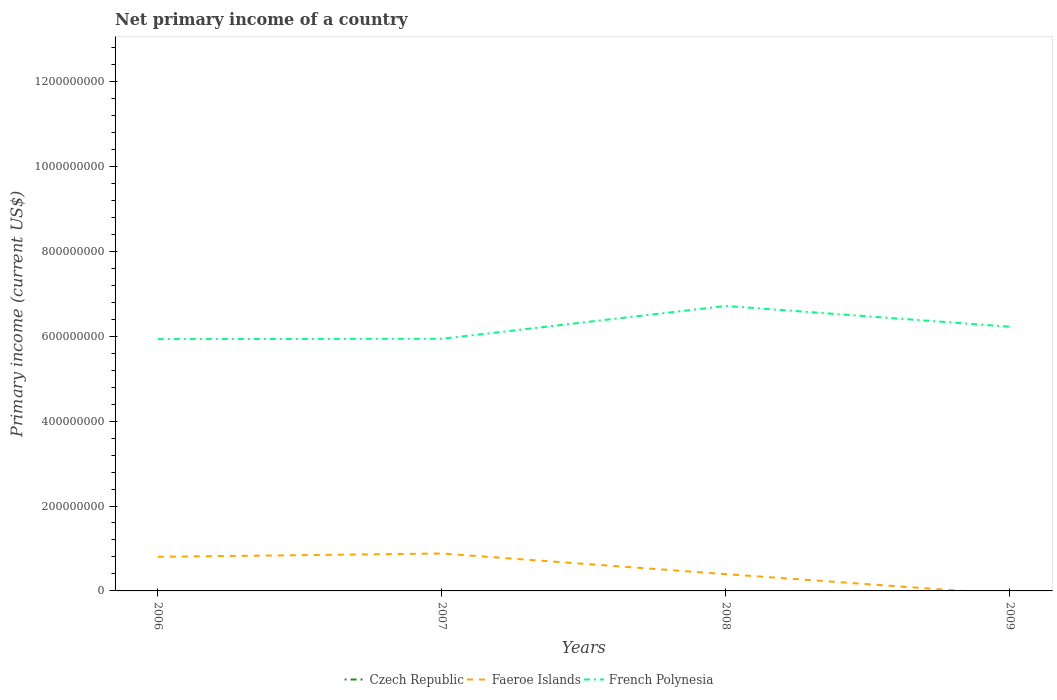Does the line corresponding to French Polynesia intersect with the line corresponding to Czech Republic?
Your response must be concise. No. Is the number of lines equal to the number of legend labels?
Give a very brief answer. No. Across all years, what is the maximum primary income in Faeroe Islands?
Provide a succinct answer. 0. What is the total primary income in Faeroe Islands in the graph?
Offer a terse response. 4.08e+07. What is the difference between the highest and the second highest primary income in Faeroe Islands?
Offer a terse response. 8.82e+07. What is the difference between the highest and the lowest primary income in Faeroe Islands?
Provide a succinct answer. 2. Is the primary income in French Polynesia strictly greater than the primary income in Czech Republic over the years?
Provide a short and direct response. No. How many lines are there?
Your answer should be compact. 2. Does the graph contain any zero values?
Provide a short and direct response. Yes. Does the graph contain grids?
Give a very brief answer. No. What is the title of the graph?
Your response must be concise. Net primary income of a country. Does "Liechtenstein" appear as one of the legend labels in the graph?
Offer a terse response. No. What is the label or title of the Y-axis?
Keep it short and to the point. Primary income (current US$). What is the Primary income (current US$) in Faeroe Islands in 2006?
Make the answer very short. 8.03e+07. What is the Primary income (current US$) of French Polynesia in 2006?
Your response must be concise. 5.93e+08. What is the Primary income (current US$) in Czech Republic in 2007?
Offer a terse response. 0. What is the Primary income (current US$) in Faeroe Islands in 2007?
Your answer should be very brief. 8.82e+07. What is the Primary income (current US$) in French Polynesia in 2007?
Ensure brevity in your answer.  5.94e+08. What is the Primary income (current US$) of Czech Republic in 2008?
Offer a very short reply. 0. What is the Primary income (current US$) in Faeroe Islands in 2008?
Ensure brevity in your answer.  3.95e+07. What is the Primary income (current US$) in French Polynesia in 2008?
Provide a succinct answer. 6.71e+08. What is the Primary income (current US$) of Czech Republic in 2009?
Ensure brevity in your answer.  0. What is the Primary income (current US$) in Faeroe Islands in 2009?
Your answer should be compact. 0. What is the Primary income (current US$) in French Polynesia in 2009?
Provide a succinct answer. 6.22e+08. Across all years, what is the maximum Primary income (current US$) of Faeroe Islands?
Offer a terse response. 8.82e+07. Across all years, what is the maximum Primary income (current US$) of French Polynesia?
Your answer should be very brief. 6.71e+08. Across all years, what is the minimum Primary income (current US$) of French Polynesia?
Offer a very short reply. 5.93e+08. What is the total Primary income (current US$) of Faeroe Islands in the graph?
Your answer should be compact. 2.08e+08. What is the total Primary income (current US$) of French Polynesia in the graph?
Offer a terse response. 2.48e+09. What is the difference between the Primary income (current US$) in Faeroe Islands in 2006 and that in 2007?
Give a very brief answer. -7.85e+06. What is the difference between the Primary income (current US$) of French Polynesia in 2006 and that in 2007?
Your answer should be compact. -8.76e+05. What is the difference between the Primary income (current US$) of Faeroe Islands in 2006 and that in 2008?
Your answer should be compact. 4.08e+07. What is the difference between the Primary income (current US$) of French Polynesia in 2006 and that in 2008?
Offer a terse response. -7.82e+07. What is the difference between the Primary income (current US$) in French Polynesia in 2006 and that in 2009?
Provide a succinct answer. -2.92e+07. What is the difference between the Primary income (current US$) in Faeroe Islands in 2007 and that in 2008?
Offer a very short reply. 4.86e+07. What is the difference between the Primary income (current US$) in French Polynesia in 2007 and that in 2008?
Keep it short and to the point. -7.73e+07. What is the difference between the Primary income (current US$) of French Polynesia in 2007 and that in 2009?
Offer a very short reply. -2.84e+07. What is the difference between the Primary income (current US$) of French Polynesia in 2008 and that in 2009?
Make the answer very short. 4.90e+07. What is the difference between the Primary income (current US$) of Faeroe Islands in 2006 and the Primary income (current US$) of French Polynesia in 2007?
Keep it short and to the point. -5.14e+08. What is the difference between the Primary income (current US$) in Faeroe Islands in 2006 and the Primary income (current US$) in French Polynesia in 2008?
Offer a very short reply. -5.91e+08. What is the difference between the Primary income (current US$) of Faeroe Islands in 2006 and the Primary income (current US$) of French Polynesia in 2009?
Ensure brevity in your answer.  -5.42e+08. What is the difference between the Primary income (current US$) of Faeroe Islands in 2007 and the Primary income (current US$) of French Polynesia in 2008?
Provide a short and direct response. -5.83e+08. What is the difference between the Primary income (current US$) in Faeroe Islands in 2007 and the Primary income (current US$) in French Polynesia in 2009?
Provide a short and direct response. -5.34e+08. What is the difference between the Primary income (current US$) in Faeroe Islands in 2008 and the Primary income (current US$) in French Polynesia in 2009?
Your answer should be very brief. -5.83e+08. What is the average Primary income (current US$) of Czech Republic per year?
Provide a succinct answer. 0. What is the average Primary income (current US$) of Faeroe Islands per year?
Keep it short and to the point. 5.20e+07. What is the average Primary income (current US$) of French Polynesia per year?
Give a very brief answer. 6.20e+08. In the year 2006, what is the difference between the Primary income (current US$) of Faeroe Islands and Primary income (current US$) of French Polynesia?
Give a very brief answer. -5.13e+08. In the year 2007, what is the difference between the Primary income (current US$) in Faeroe Islands and Primary income (current US$) in French Polynesia?
Offer a terse response. -5.06e+08. In the year 2008, what is the difference between the Primary income (current US$) in Faeroe Islands and Primary income (current US$) in French Polynesia?
Your answer should be very brief. -6.32e+08. What is the ratio of the Primary income (current US$) in Faeroe Islands in 2006 to that in 2007?
Offer a very short reply. 0.91. What is the ratio of the Primary income (current US$) in French Polynesia in 2006 to that in 2007?
Ensure brevity in your answer.  1. What is the ratio of the Primary income (current US$) of Faeroe Islands in 2006 to that in 2008?
Provide a succinct answer. 2.03. What is the ratio of the Primary income (current US$) in French Polynesia in 2006 to that in 2008?
Give a very brief answer. 0.88. What is the ratio of the Primary income (current US$) of French Polynesia in 2006 to that in 2009?
Your answer should be compact. 0.95. What is the ratio of the Primary income (current US$) of Faeroe Islands in 2007 to that in 2008?
Offer a terse response. 2.23. What is the ratio of the Primary income (current US$) in French Polynesia in 2007 to that in 2008?
Offer a very short reply. 0.88. What is the ratio of the Primary income (current US$) of French Polynesia in 2007 to that in 2009?
Keep it short and to the point. 0.95. What is the ratio of the Primary income (current US$) in French Polynesia in 2008 to that in 2009?
Offer a terse response. 1.08. What is the difference between the highest and the second highest Primary income (current US$) in Faeroe Islands?
Give a very brief answer. 7.85e+06. What is the difference between the highest and the second highest Primary income (current US$) of French Polynesia?
Give a very brief answer. 4.90e+07. What is the difference between the highest and the lowest Primary income (current US$) of Faeroe Islands?
Offer a terse response. 8.82e+07. What is the difference between the highest and the lowest Primary income (current US$) of French Polynesia?
Your answer should be compact. 7.82e+07. 